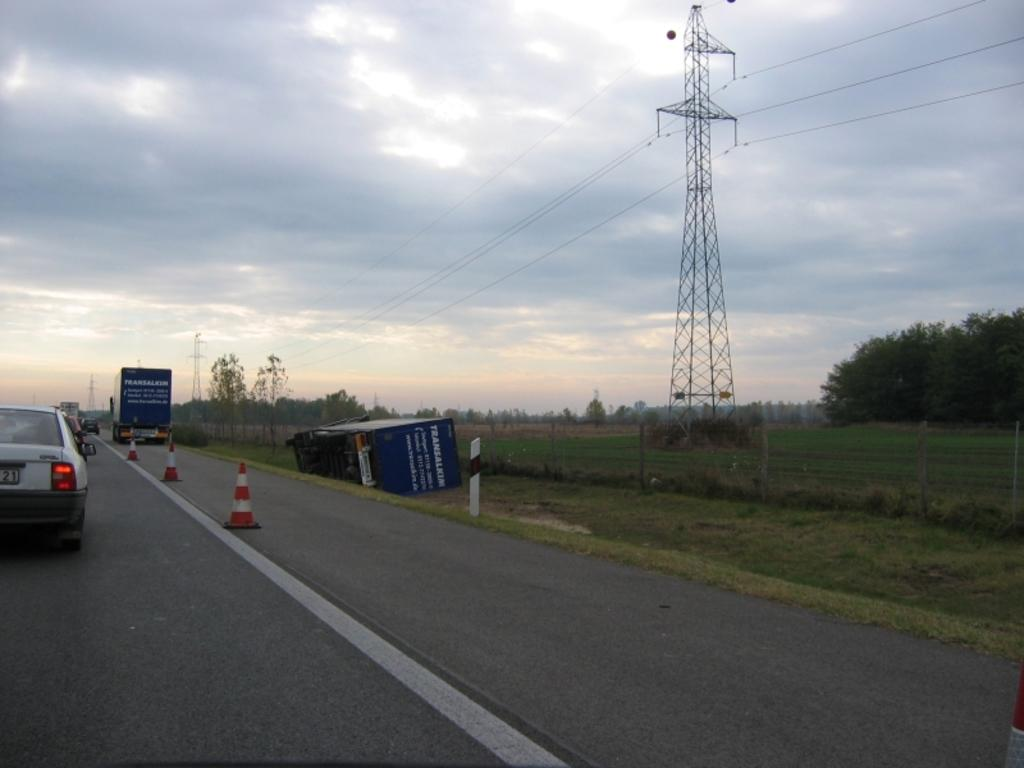Where was the image taken? The image was clicked outside. What can be seen in the middle of the image? There are trees and a tower in the middle of the image. What is visible at the top of the image? The sky is visible at the top of the image. What type of vehicles are on the left side of the image? There are cars on the left side of the image. How many pizzas are being delivered in the image? There are no pizzas or delivery in the image. What type of trouble can be seen in the image? There is no trouble or problem depicted in the image. 